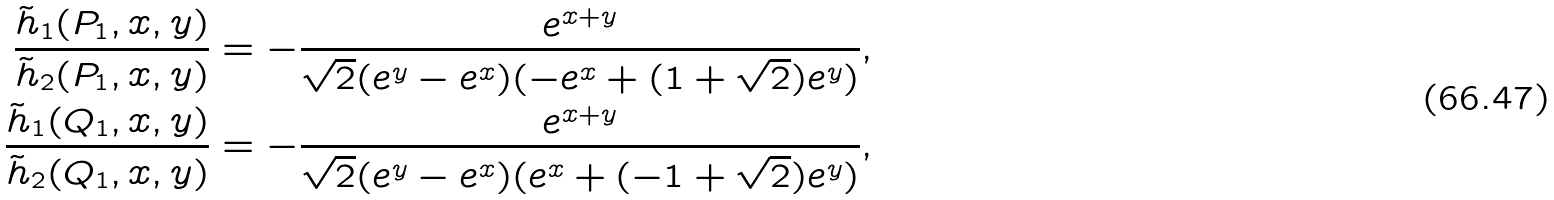<formula> <loc_0><loc_0><loc_500><loc_500>\frac { { \tilde { h } _ { 1 } } ( P _ { 1 } , x , y ) } { { \tilde { h } _ { 2 } } ( P _ { 1 } , x , y ) } = - \frac { e ^ { x + y } } { \sqrt { 2 } ( e ^ { y } - e ^ { x } ) ( - e ^ { x } + ( 1 + \sqrt { 2 } ) e ^ { y } ) } , \\ \frac { \tilde { h } _ { 1 } ( Q _ { 1 } , x , y ) } { \tilde { h } _ { 2 } ( Q _ { 1 } , x , y ) } = - \frac { e ^ { x + y } } { \sqrt { 2 } ( e ^ { y } - e ^ { x } ) ( e ^ { x } + ( - 1 + \sqrt { 2 } ) e ^ { y } ) } ,</formula> 